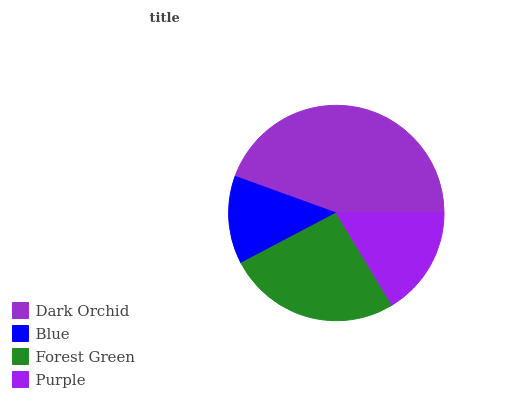Is Blue the minimum?
Answer yes or no. Yes. Is Dark Orchid the maximum?
Answer yes or no. Yes. Is Forest Green the minimum?
Answer yes or no. No. Is Forest Green the maximum?
Answer yes or no. No. Is Forest Green greater than Blue?
Answer yes or no. Yes. Is Blue less than Forest Green?
Answer yes or no. Yes. Is Blue greater than Forest Green?
Answer yes or no. No. Is Forest Green less than Blue?
Answer yes or no. No. Is Forest Green the high median?
Answer yes or no. Yes. Is Purple the low median?
Answer yes or no. Yes. Is Blue the high median?
Answer yes or no. No. Is Dark Orchid the low median?
Answer yes or no. No. 